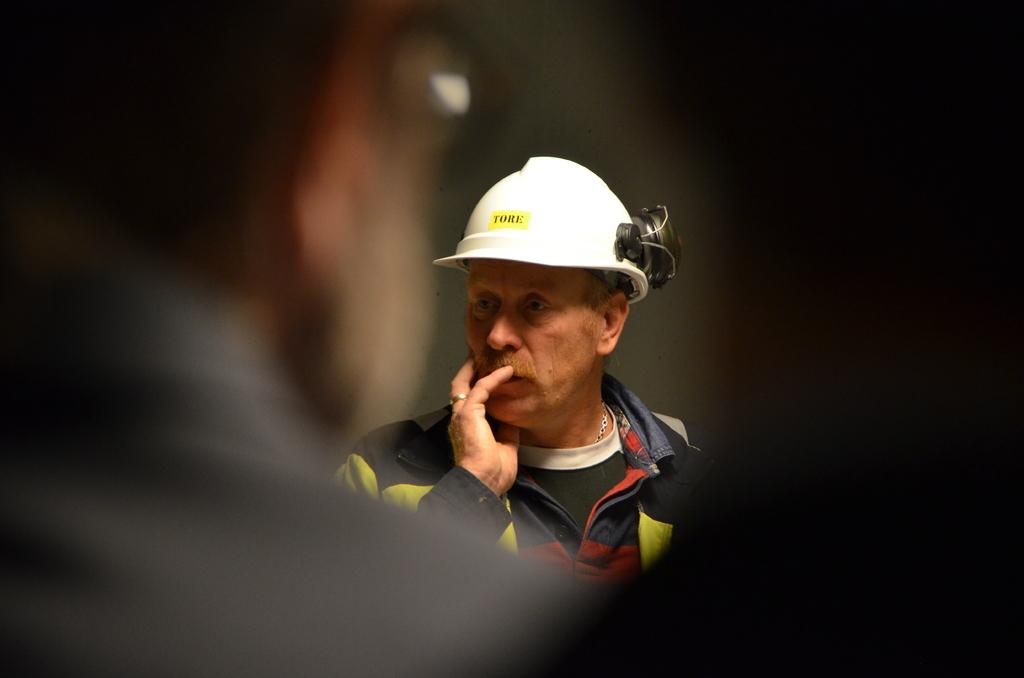What is the main subject of the image? The main subject of the image is a group of people. Can you describe the man in the middle of the image? The man in the middle of the image is wearing a helmet. What might the presence of the helmet suggest about the man's activity or role in the image? The helmet might suggest that the man is engaged in an activity that requires protective gear, such as a sport or construction work. What type of sofa can be seen in the background of the image? There is no sofa present in the image. What ingredients are used to make the stew that is being served in the image? There is no stew present in the image. 